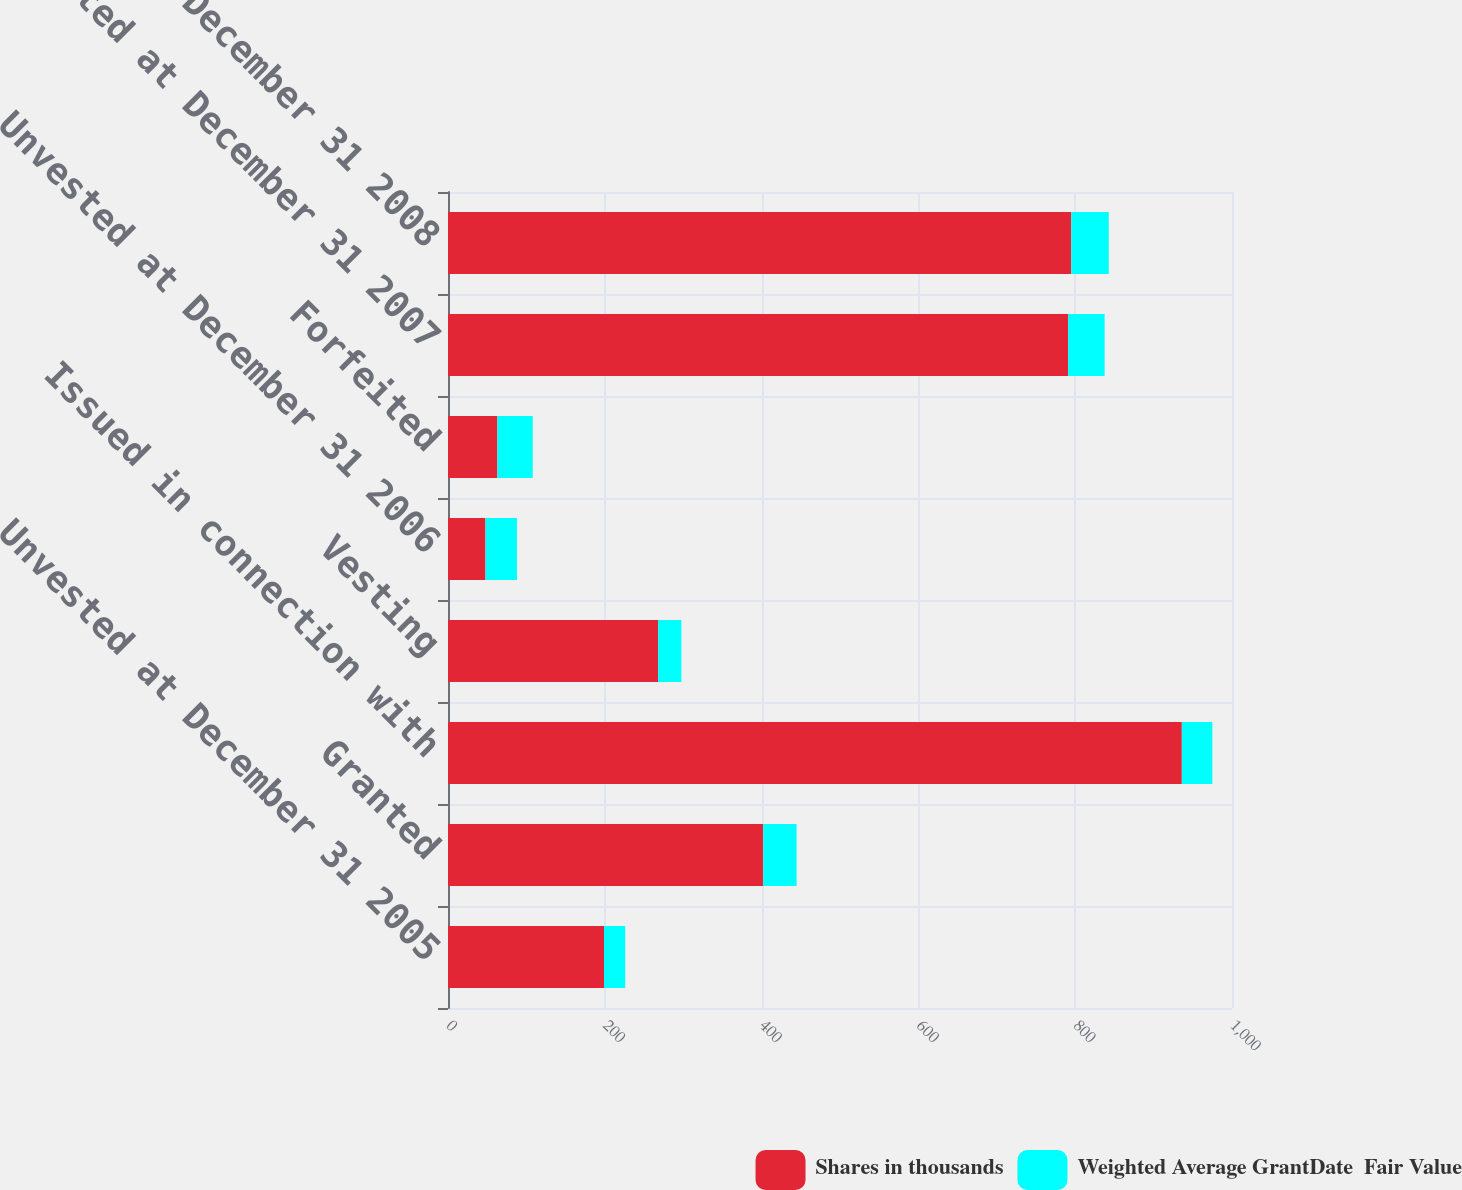<chart> <loc_0><loc_0><loc_500><loc_500><stacked_bar_chart><ecel><fcel>Unvested at December 31 2005<fcel>Granted<fcel>Issued in connection with<fcel>Vesting<fcel>Unvested at December 31 2006<fcel>Forfeited<fcel>Unvested at December 31 2007<fcel>Unvested at December 31 2008<nl><fcel>Shares in thousands<fcel>199<fcel>402<fcel>936<fcel>268<fcel>47.8<fcel>63<fcel>791<fcel>795<nl><fcel>Weighted Average GrantDate  Fair Value<fcel>27.03<fcel>42.66<fcel>38.93<fcel>29.62<fcel>40.21<fcel>45.07<fcel>46.55<fcel>47.8<nl></chart> 